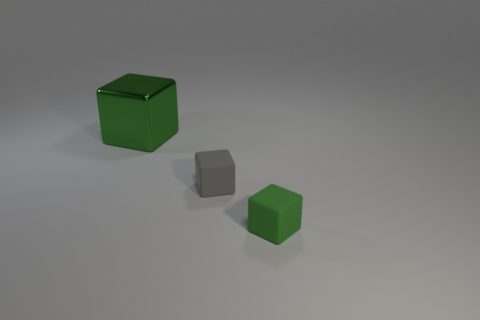Add 1 big metallic cubes. How many objects exist? 4 Subtract 0 cyan spheres. How many objects are left? 3 Subtract all small gray rubber objects. Subtract all cyan rubber cylinders. How many objects are left? 2 Add 1 gray cubes. How many gray cubes are left? 2 Add 1 tiny green blocks. How many tiny green blocks exist? 2 